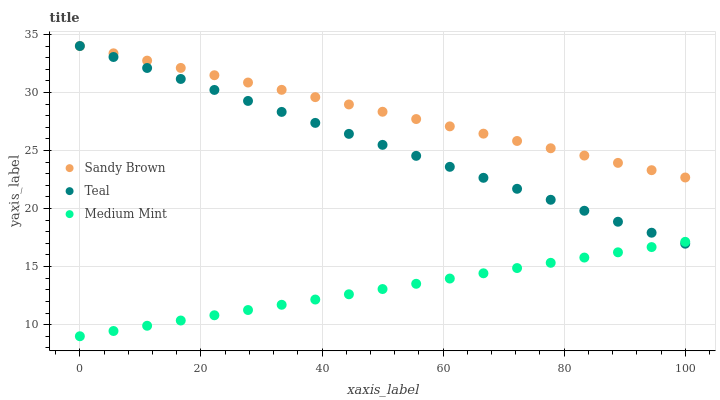Does Medium Mint have the minimum area under the curve?
Answer yes or no. Yes. Does Sandy Brown have the maximum area under the curve?
Answer yes or no. Yes. Does Teal have the minimum area under the curve?
Answer yes or no. No. Does Teal have the maximum area under the curve?
Answer yes or no. No. Is Medium Mint the smoothest?
Answer yes or no. Yes. Is Sandy Brown the roughest?
Answer yes or no. Yes. Is Teal the smoothest?
Answer yes or no. No. Is Teal the roughest?
Answer yes or no. No. Does Medium Mint have the lowest value?
Answer yes or no. Yes. Does Teal have the lowest value?
Answer yes or no. No. Does Teal have the highest value?
Answer yes or no. Yes. Is Medium Mint less than Sandy Brown?
Answer yes or no. Yes. Is Sandy Brown greater than Medium Mint?
Answer yes or no. Yes. Does Teal intersect Medium Mint?
Answer yes or no. Yes. Is Teal less than Medium Mint?
Answer yes or no. No. Is Teal greater than Medium Mint?
Answer yes or no. No. Does Medium Mint intersect Sandy Brown?
Answer yes or no. No. 